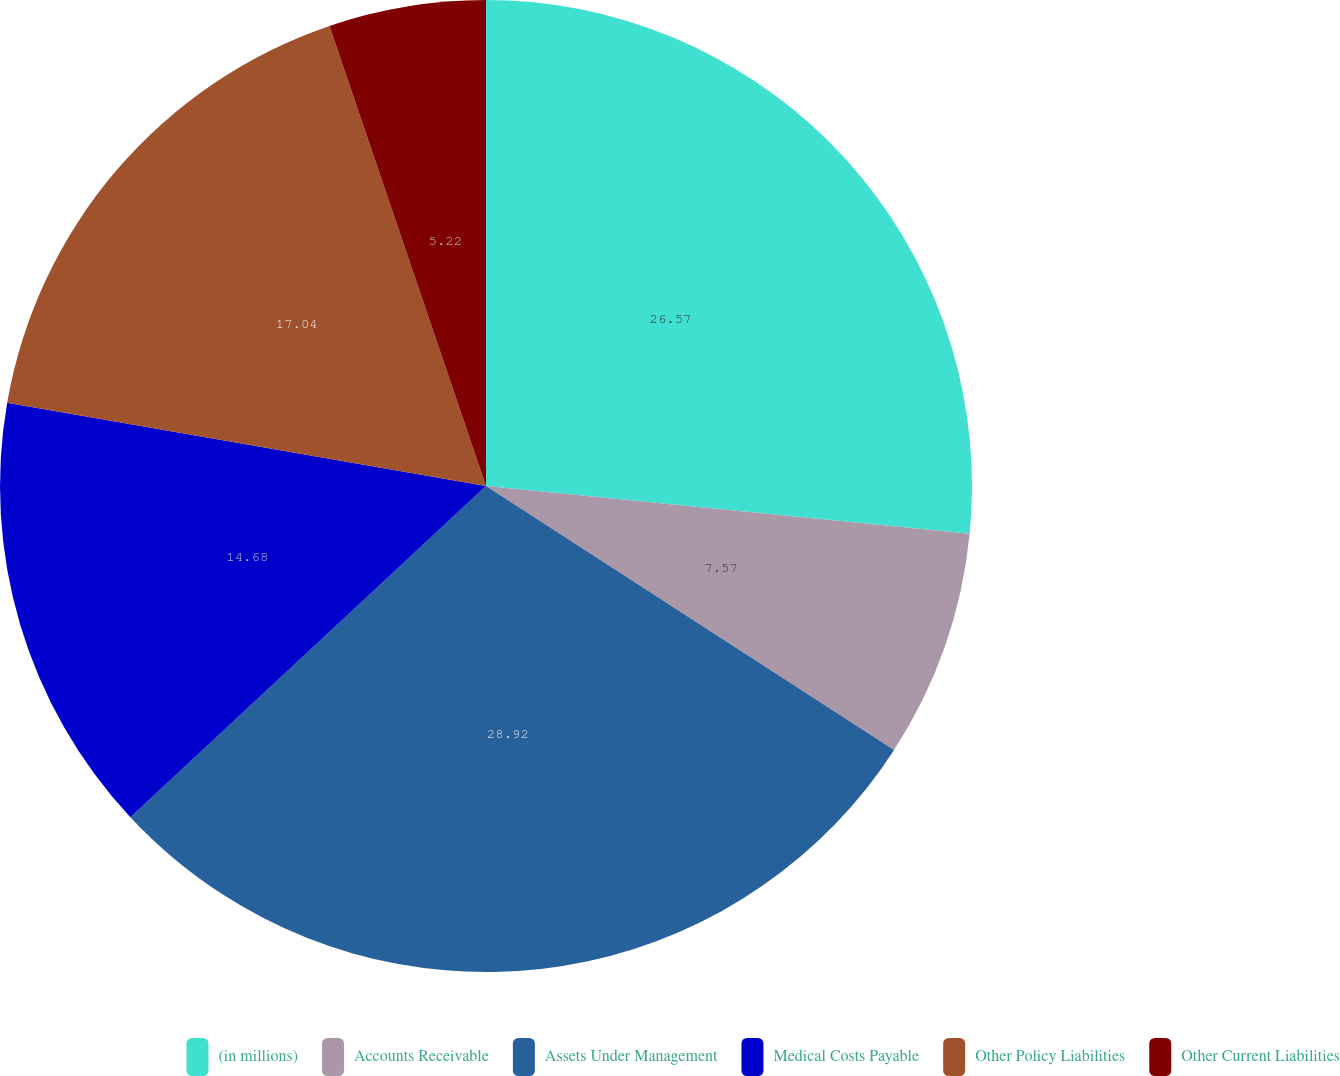Convert chart. <chart><loc_0><loc_0><loc_500><loc_500><pie_chart><fcel>(in millions)<fcel>Accounts Receivable<fcel>Assets Under Management<fcel>Medical Costs Payable<fcel>Other Policy Liabilities<fcel>Other Current Liabilities<nl><fcel>26.57%<fcel>7.57%<fcel>28.93%<fcel>14.68%<fcel>17.04%<fcel>5.22%<nl></chart> 